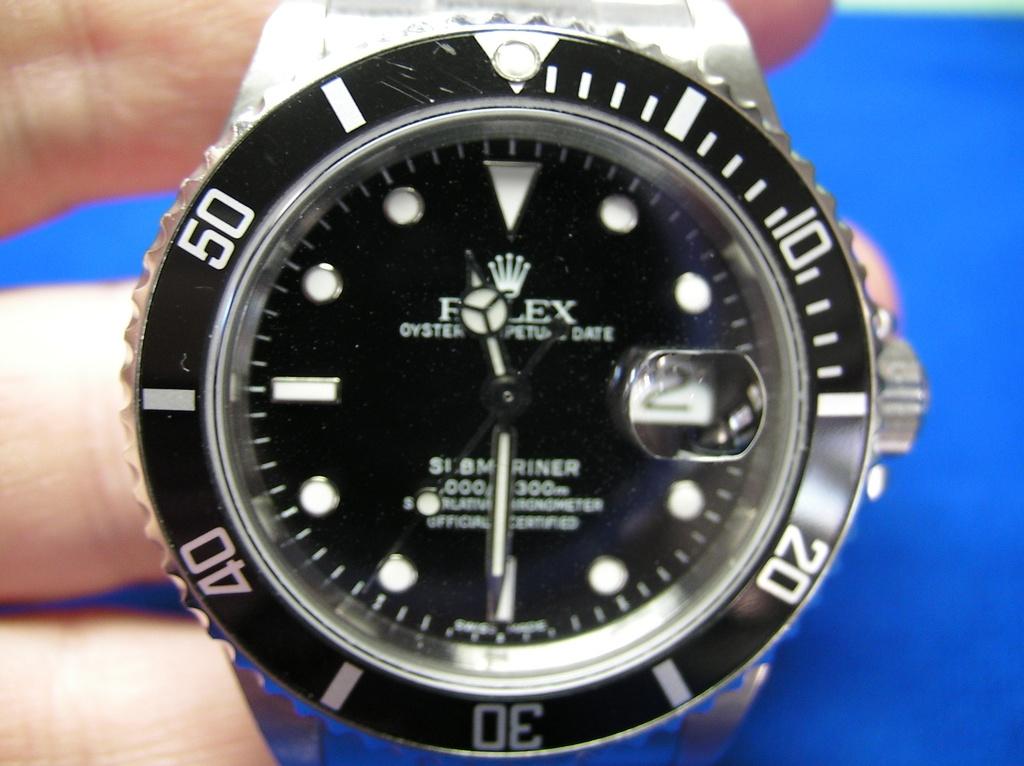What is the brand of this watch?
Keep it short and to the point. Rolex. What time is it on the watch?
Offer a terse response. 11:30. 